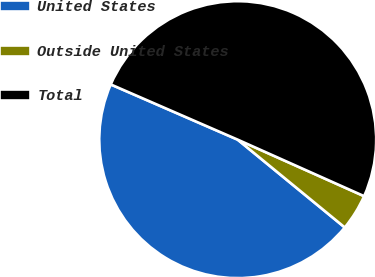Convert chart. <chart><loc_0><loc_0><loc_500><loc_500><pie_chart><fcel>United States<fcel>Outside United States<fcel>Total<nl><fcel>45.6%<fcel>4.24%<fcel>50.16%<nl></chart> 